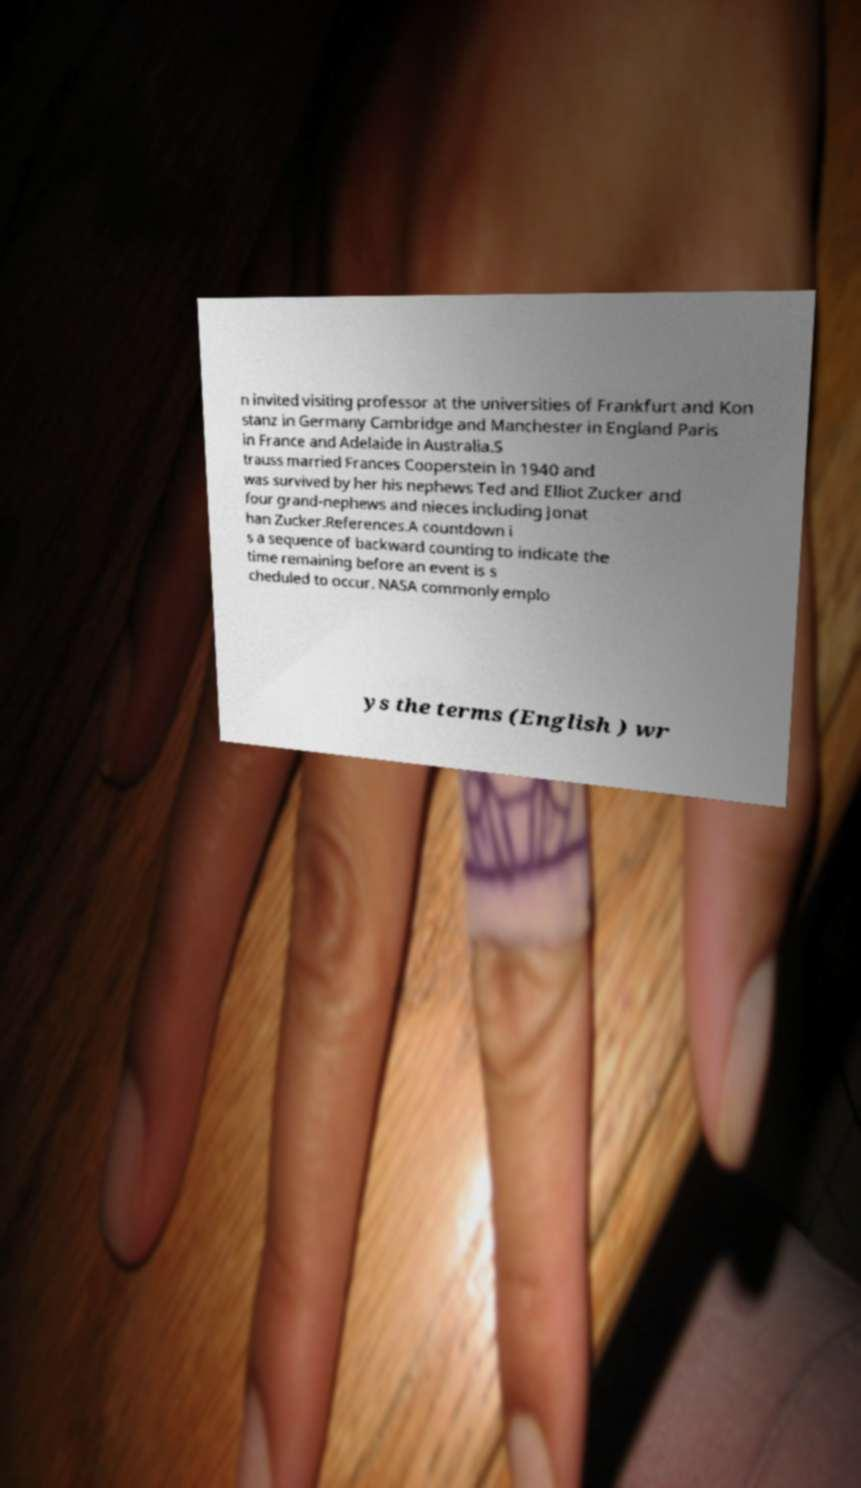I need the written content from this picture converted into text. Can you do that? n invited visiting professor at the universities of Frankfurt and Kon stanz in Germany Cambridge and Manchester in England Paris in France and Adelaide in Australia.S trauss married Frances Cooperstein in 1940 and was survived by her his nephews Ted and Elliot Zucker and four grand-nephews and nieces including Jonat han Zucker.References.A countdown i s a sequence of backward counting to indicate the time remaining before an event is s cheduled to occur. NASA commonly emplo ys the terms (English ) wr 